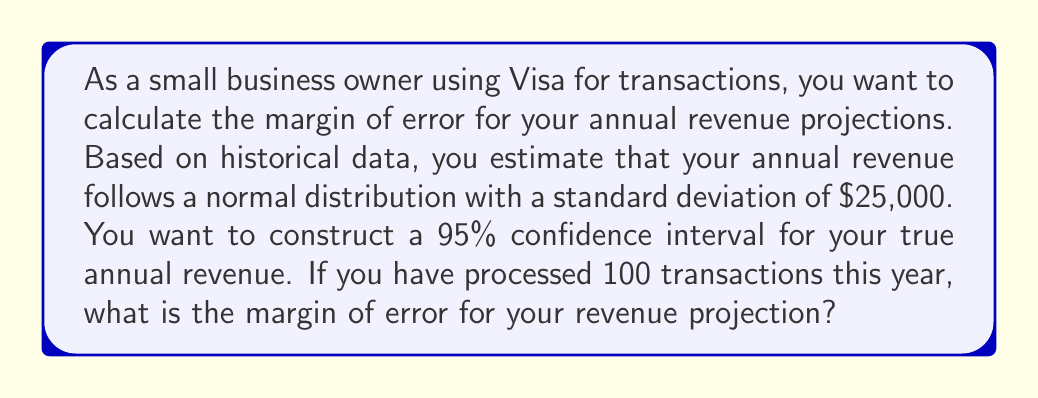Can you solve this math problem? To calculate the margin of error for the annual revenue projection, we'll follow these steps:

1. Identify the known values:
   - Confidence level: 95%
   - Sample size (n): 100 transactions
   - Standard deviation (σ): $25,000

2. Find the z-score for a 95% confidence interval:
   The z-score for a 95% confidence interval is 1.96.

3. Use the margin of error formula:
   $$ \text{Margin of Error} = z \cdot \frac{\sigma}{\sqrt{n}} $$

   Where:
   z = z-score for the desired confidence level
   σ = standard deviation of the population
   n = sample size

4. Plug in the values:
   $$ \text{Margin of Error} = 1.96 \cdot \frac{25,000}{\sqrt{100}} $$

5. Simplify:
   $$ \text{Margin of Error} = 1.96 \cdot \frac{25,000}{10} = 1.96 \cdot 2,500 = 4,900 $$

Therefore, the margin of error for the annual revenue projection is $4,900.
Answer: $4,900 